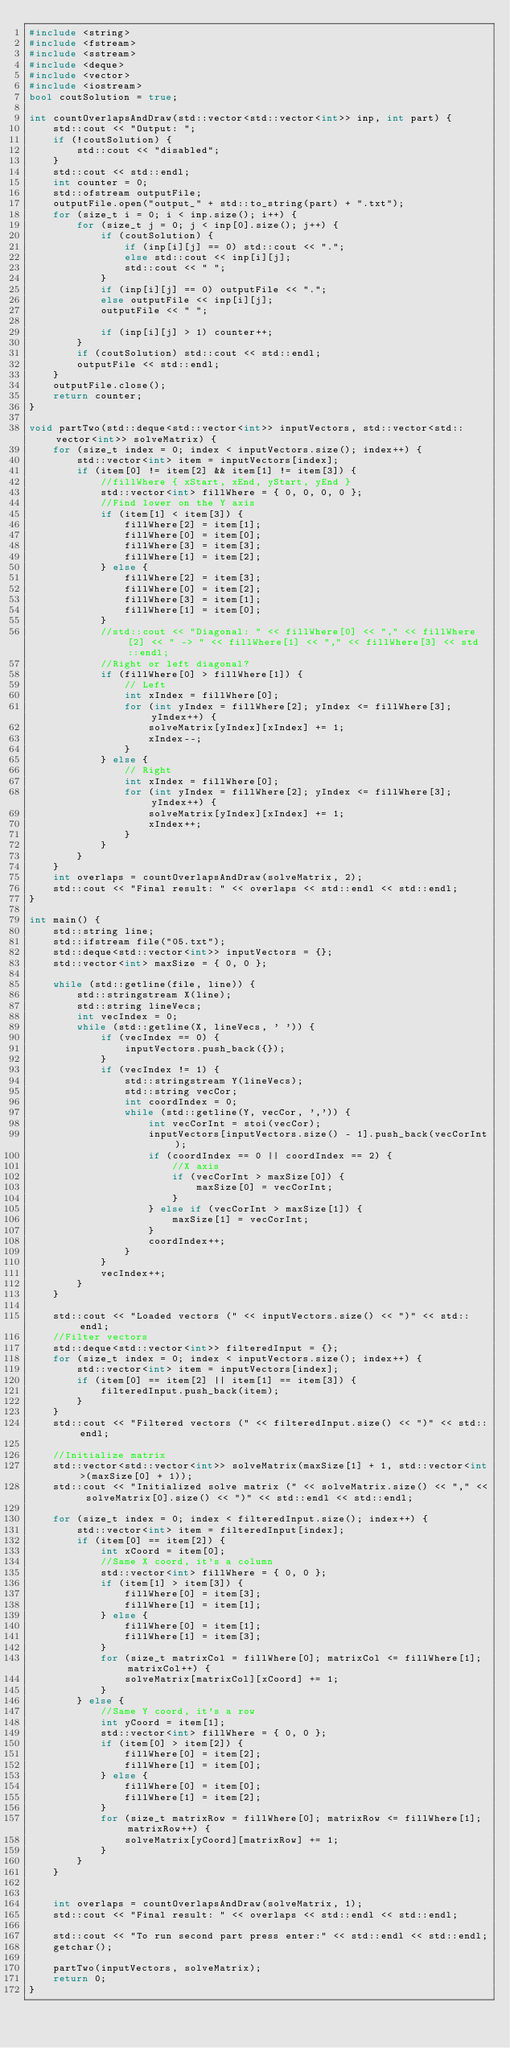Convert code to text. <code><loc_0><loc_0><loc_500><loc_500><_C++_>#include <string>
#include <fstream>
#include <sstream>
#include <deque>
#include <vector>
#include <iostream>
bool coutSolution = true;

int countOverlapsAndDraw(std::vector<std::vector<int>> inp, int part) {
	std::cout << "Output: ";
	if (!coutSolution) {
		std::cout << "disabled";
	}
	std::cout << std::endl;
	int counter = 0;
	std::ofstream outputFile;
	outputFile.open("output_" + std::to_string(part) + ".txt");
	for (size_t i = 0; i < inp.size(); i++) {
		for (size_t j = 0; j < inp[0].size(); j++) {
			if (coutSolution) {
				if (inp[i][j] == 0) std::cout << ".";
				else std::cout << inp[i][j];
				std::cout << " ";
			}
			if (inp[i][j] == 0) outputFile << ".";
			else outputFile << inp[i][j];
			outputFile << " ";

			if (inp[i][j] > 1) counter++;
		}
		if (coutSolution) std::cout << std::endl;
		outputFile << std::endl;
	}
	outputFile.close();
	return counter;
}

void partTwo(std::deque<std::vector<int>> inputVectors, std::vector<std::vector<int>> solveMatrix) {
	for (size_t index = 0; index < inputVectors.size(); index++) {
		std::vector<int> item = inputVectors[index];
		if (item[0] != item[2] && item[1] != item[3]) {
			//fillWhere { xStart, xEnd, yStart, yEnd }
			std::vector<int> fillWhere = { 0, 0, 0, 0 };
			//Find lower on the Y axis
			if (item[1] < item[3]) {
				fillWhere[2] = item[1];
				fillWhere[0] = item[0];
				fillWhere[3] = item[3];
				fillWhere[1] = item[2];
			} else {
				fillWhere[2] = item[3];
				fillWhere[0] = item[2];
				fillWhere[3] = item[1];
				fillWhere[1] = item[0];
			}
			//std::cout << "Diagonal: " << fillWhere[0] << "," << fillWhere[2] << " -> " << fillWhere[1] << "," << fillWhere[3] << std::endl;
			//Right or left diagonal?
			if (fillWhere[0] > fillWhere[1]) {
				// Left
				int xIndex = fillWhere[0];
				for (int yIndex = fillWhere[2]; yIndex <= fillWhere[3]; yIndex++) {
					solveMatrix[yIndex][xIndex] += 1;
					xIndex--;
				}
			} else {
				// Right
				int xIndex = fillWhere[0];
				for (int yIndex = fillWhere[2]; yIndex <= fillWhere[3]; yIndex++) {
					solveMatrix[yIndex][xIndex] += 1;
					xIndex++;
				}
			}
		}
	}
	int overlaps = countOverlapsAndDraw(solveMatrix, 2);
 	std::cout << "Final result: " << overlaps << std::endl << std::endl;
}

int main() {
	std::string line;
	std::ifstream file("05.txt");
	std::deque<std::vector<int>> inputVectors = {};
	std::vector<int> maxSize = { 0, 0 };

	while (std::getline(file, line)) {
		std::stringstream X(line);
		std::string lineVecs;
		int vecIndex = 0;
		while (std::getline(X, lineVecs, ' ')) {
			if (vecIndex == 0) {
				inputVectors.push_back({});
			}
			if (vecIndex != 1) {
				std::stringstream Y(lineVecs);
				std::string vecCor;
				int coordIndex = 0;
				while (std::getline(Y, vecCor, ',')) {
					int vecCorInt = stoi(vecCor);
					inputVectors[inputVectors.size() - 1].push_back(vecCorInt);
					if (coordIndex == 0 || coordIndex == 2) {
						//X axis
						if (vecCorInt > maxSize[0]) {
							maxSize[0] = vecCorInt;
						}
					} else if (vecCorInt > maxSize[1]) {
						maxSize[1] = vecCorInt;
					}
					coordIndex++;
				}
			}
			vecIndex++;
		}
	}

	std::cout << "Loaded vectors (" << inputVectors.size() << ")" << std::endl;
	//Filter vectors
	std::deque<std::vector<int>> filteredInput = {};
	for (size_t index = 0; index < inputVectors.size(); index++) {
		std::vector<int> item = inputVectors[index];
		if (item[0] == item[2] || item[1] == item[3]) {
			filteredInput.push_back(item);
		}
	}
	std::cout << "Filtered vectors (" << filteredInput.size() << ")" << std::endl;

	//Initialize matrix
	std::vector<std::vector<int>> solveMatrix(maxSize[1] + 1, std::vector<int>(maxSize[0] + 1));
	std::cout << "Initialized solve matrix (" << solveMatrix.size() << "," << solveMatrix[0].size() << ")" << std::endl << std::endl;

	for (size_t index = 0; index < filteredInput.size(); index++) {
		std::vector<int> item = filteredInput[index];
		if (item[0] == item[2]) {
			int xCoord = item[0];
			//Same X coord, it's a column
			std::vector<int> fillWhere = { 0, 0 };
			if (item[1] > item[3]) {
				fillWhere[0] = item[3];
				fillWhere[1] = item[1];
			} else {
				fillWhere[0] = item[1];
				fillWhere[1] = item[3];
			}
			for (size_t matrixCol = fillWhere[0]; matrixCol <= fillWhere[1]; matrixCol++) {
				solveMatrix[matrixCol][xCoord] += 1;
			}
		} else {
			//Same Y coord, it's a row
			int yCoord = item[1];
			std::vector<int> fillWhere = { 0, 0 };
			if (item[0] > item[2]) {
				fillWhere[0] = item[2];
				fillWhere[1] = item[0];
			} else {
				fillWhere[0] = item[0];
				fillWhere[1] = item[2];
			}
			for (size_t matrixRow = fillWhere[0]; matrixRow <= fillWhere[1]; matrixRow++) {
				solveMatrix[yCoord][matrixRow] += 1;
			}
		}
	}


	int overlaps = countOverlapsAndDraw(solveMatrix, 1);
	std::cout << "Final result: " << overlaps << std::endl << std::endl;

	std::cout << "To run second part press enter:" << std::endl << std::endl;
	getchar();

	partTwo(inputVectors, solveMatrix);
	return 0;
}</code> 